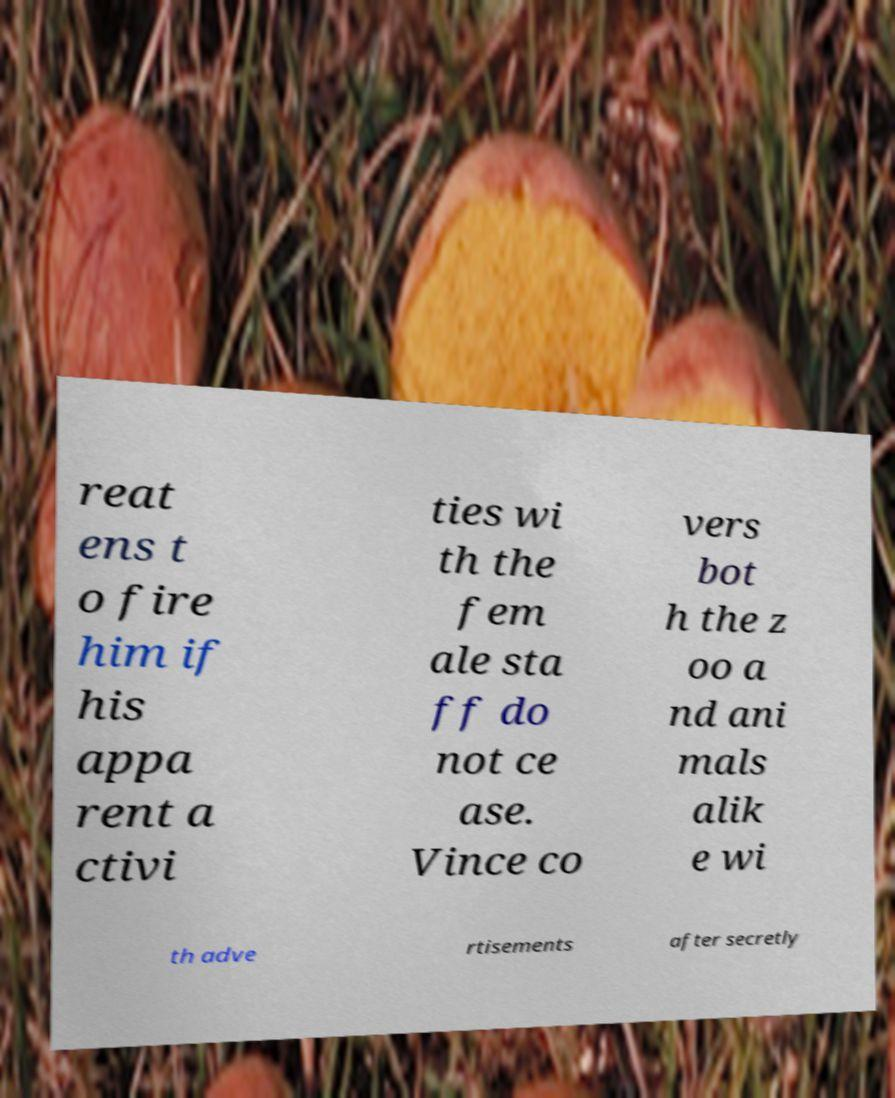Please identify and transcribe the text found in this image. reat ens t o fire him if his appa rent a ctivi ties wi th the fem ale sta ff do not ce ase. Vince co vers bot h the z oo a nd ani mals alik e wi th adve rtisements after secretly 